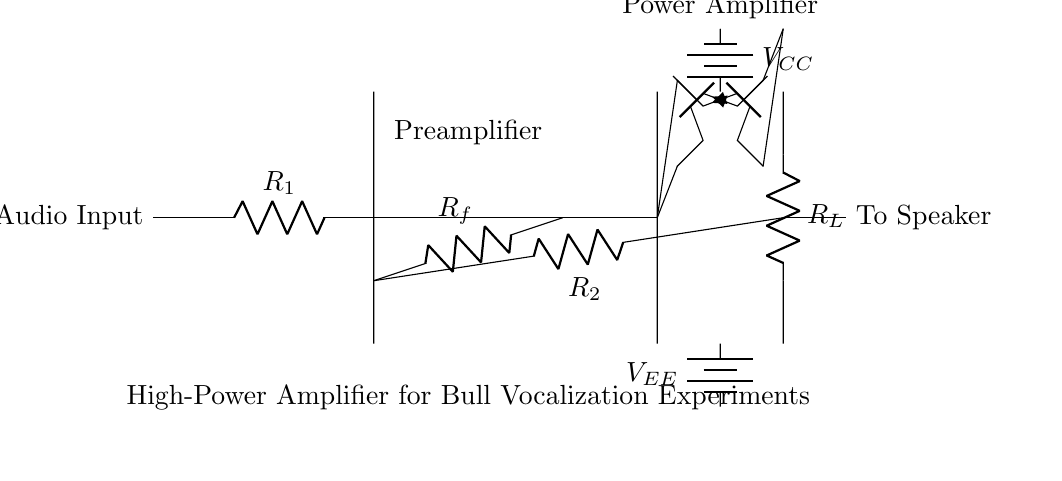What component is used for audio input? The circuit shows that the audio input is connected directly to the first resistor, which functions as a part of the input stage before amplification.
Answer: Resistor What is the function of the operational amplifier in this circuit? The operational amplifier serves as a preamplifier, boosting the audio signal strength before it reaches the power amplifier stage.
Answer: Preamplifier What are the names of the transistors used in the power amplifier stage? The diagram indicates the use of a PNP transistor named Qp and an NPN transistor named Qn for the power amplification process.
Answer: Qp and Qn What is the significant power supply voltage in this amplifier circuit? The circuit features two power supply voltages from batteries, labeled VCC for positive and VEE for negative, indicating the dual power supply configuration necessary for the operation of the amplifier.
Answer: VCC and VEE How does feedback work in this amplifier circuit? Feedback is implemented through the resistor labeled R2, which connects the output back to the input stage, influencing the overall gain and stability of the amplifier operation.
Answer: Resistor What type of load resistor is connected at the output? The load resistor labeled R_L is connected at the output stage to match the impedance with the speaker, allowing for efficient audio signal transfer.
Answer: R_L 